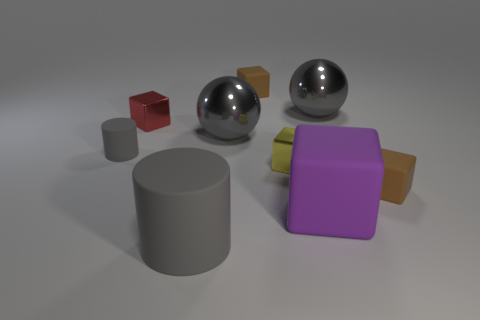What shape is the thing that is behind the red object and to the right of the purple thing?
Ensure brevity in your answer.  Sphere. Is the number of small blocks in front of the large cube greater than the number of large gray metal balls?
Provide a succinct answer. No. There is a yellow thing that is the same material as the red block; what size is it?
Your response must be concise. Small. What number of other matte cylinders are the same color as the small rubber cylinder?
Ensure brevity in your answer.  1. There is a matte thing behind the tiny red block; is its color the same as the large block?
Provide a succinct answer. No. Are there an equal number of tiny red metal objects in front of the large purple cube and tiny yellow shiny blocks to the right of the tiny yellow metallic block?
Make the answer very short. Yes. Is there any other thing that has the same material as the big gray cylinder?
Ensure brevity in your answer.  Yes. The small metallic cube that is on the right side of the large gray matte object is what color?
Make the answer very short. Yellow. Is the number of objects that are left of the yellow block the same as the number of large gray balls?
Provide a short and direct response. No. How many other things are there of the same shape as the big purple matte object?
Ensure brevity in your answer.  4. 